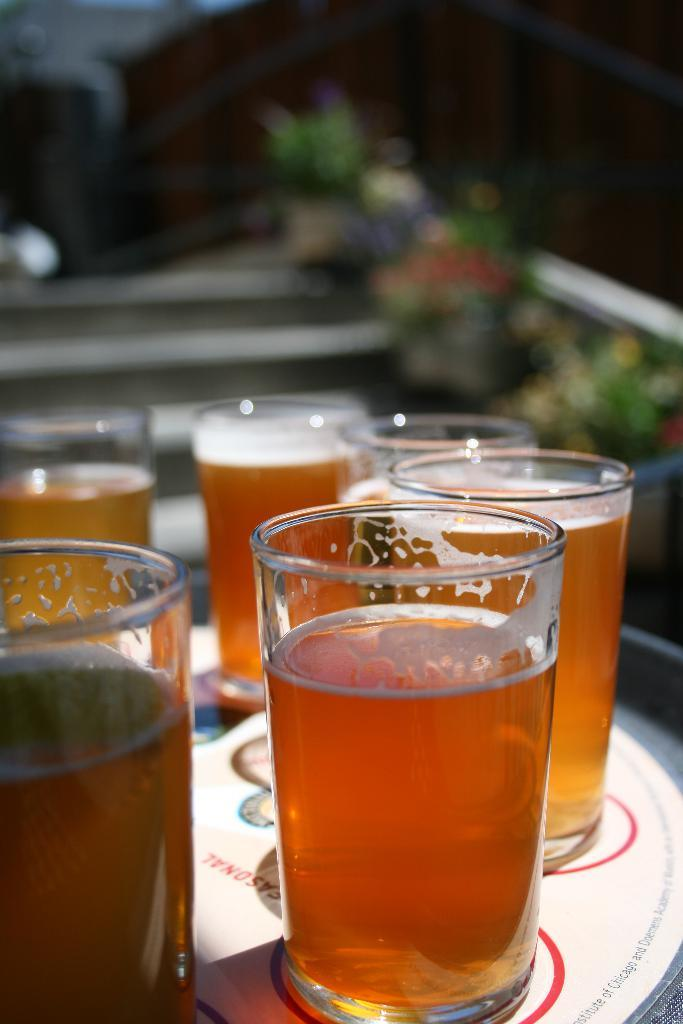What objects are in the foreground of the image? There are glasses filled with drinks in the foreground of the image. Where are the glasses placed? The glasses are placed on a table. Can you describe the background of the image? The background of the image is blurred. How many degrees can be seen on the island in the image? There is no island present in the image, and therefore no degrees to count. 